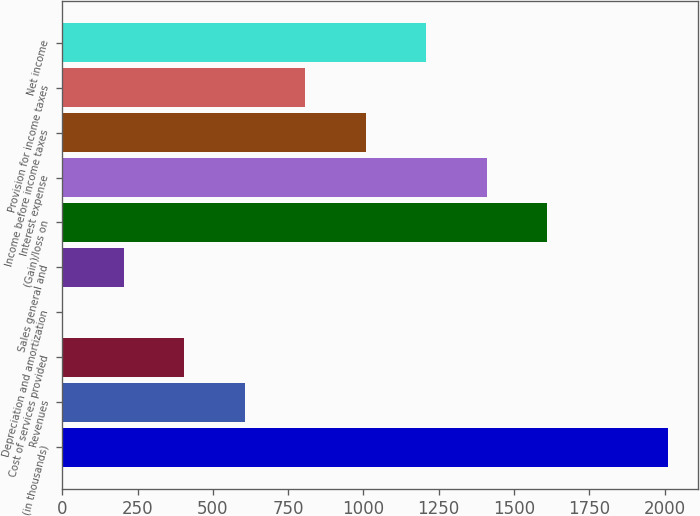Convert chart. <chart><loc_0><loc_0><loc_500><loc_500><bar_chart><fcel>(in thousands)<fcel>Revenues<fcel>Cost of services provided<fcel>Depreciation and amortization<fcel>Sales general and<fcel>(Gain)/loss on<fcel>Interest expense<fcel>Income before income taxes<fcel>Provision for income taxes<fcel>Net income<nl><fcel>2012<fcel>605.77<fcel>404.88<fcel>3.1<fcel>203.99<fcel>1610.22<fcel>1409.33<fcel>1007.55<fcel>806.66<fcel>1208.44<nl></chart> 